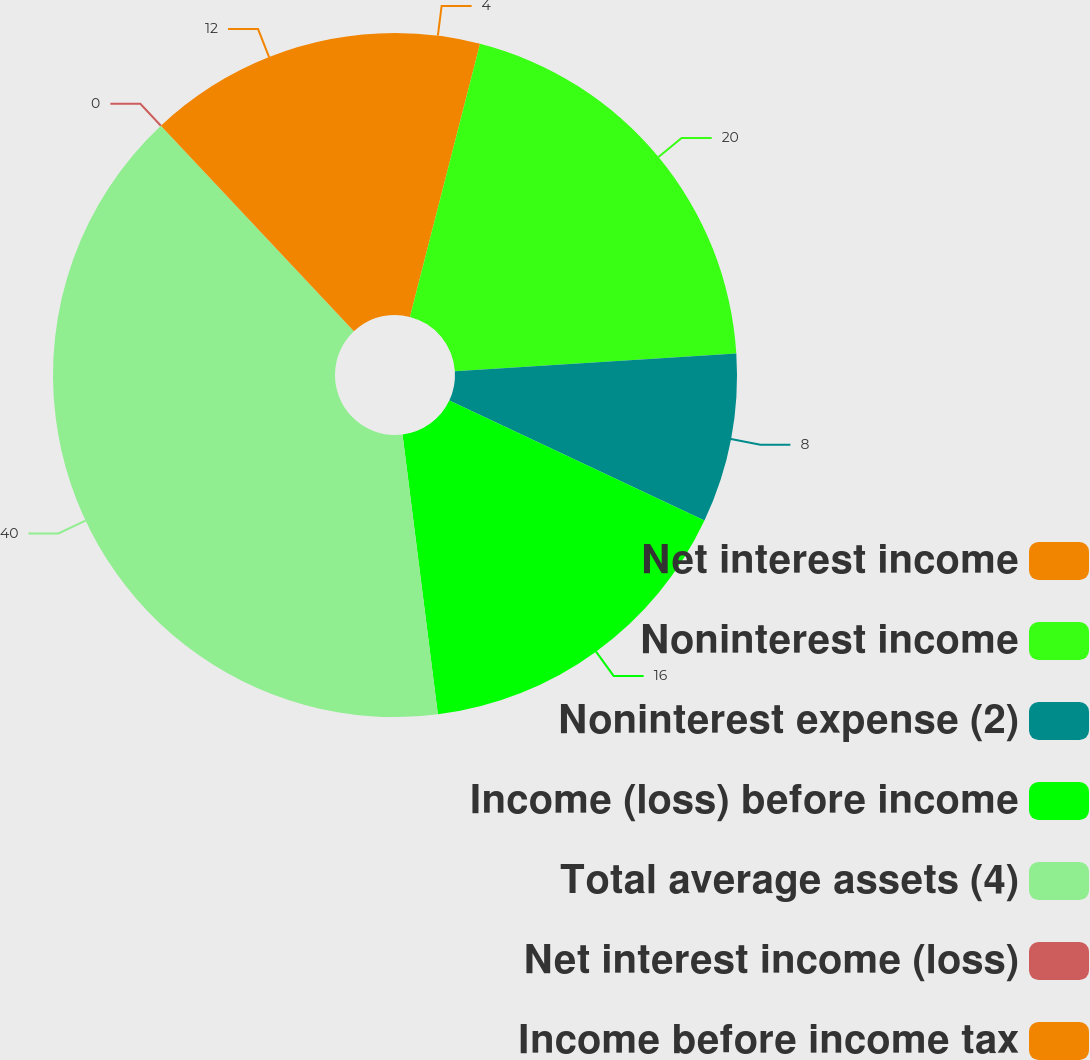Convert chart to OTSL. <chart><loc_0><loc_0><loc_500><loc_500><pie_chart><fcel>Net interest income<fcel>Noninterest income<fcel>Noninterest expense (2)<fcel>Income (loss) before income<fcel>Total average assets (4)<fcel>Net interest income (loss)<fcel>Income before income tax<nl><fcel>4.0%<fcel>20.0%<fcel>8.0%<fcel>16.0%<fcel>40.0%<fcel>0.0%<fcel>12.0%<nl></chart> 